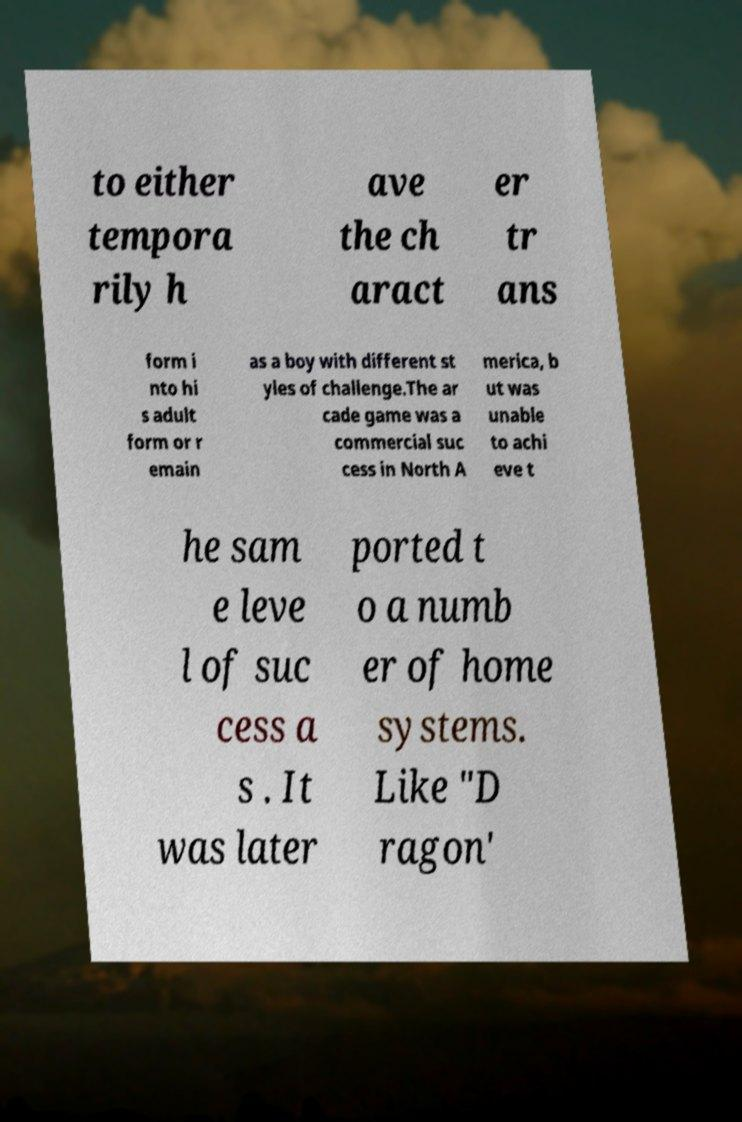There's text embedded in this image that I need extracted. Can you transcribe it verbatim? to either tempora rily h ave the ch aract er tr ans form i nto hi s adult form or r emain as a boy with different st yles of challenge.The ar cade game was a commercial suc cess in North A merica, b ut was unable to achi eve t he sam e leve l of suc cess a s . It was later ported t o a numb er of home systems. Like "D ragon' 